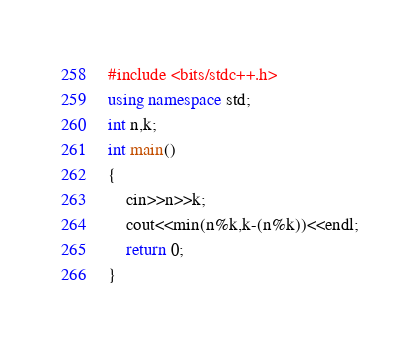<code> <loc_0><loc_0><loc_500><loc_500><_C++_>#include <bits/stdc++.h>
using namespace std;
int n,k;
int main()
{
	cin>>n>>k;
	cout<<min(n%k,k-(n%k))<<endl;
	return 0; 
}
</code> 